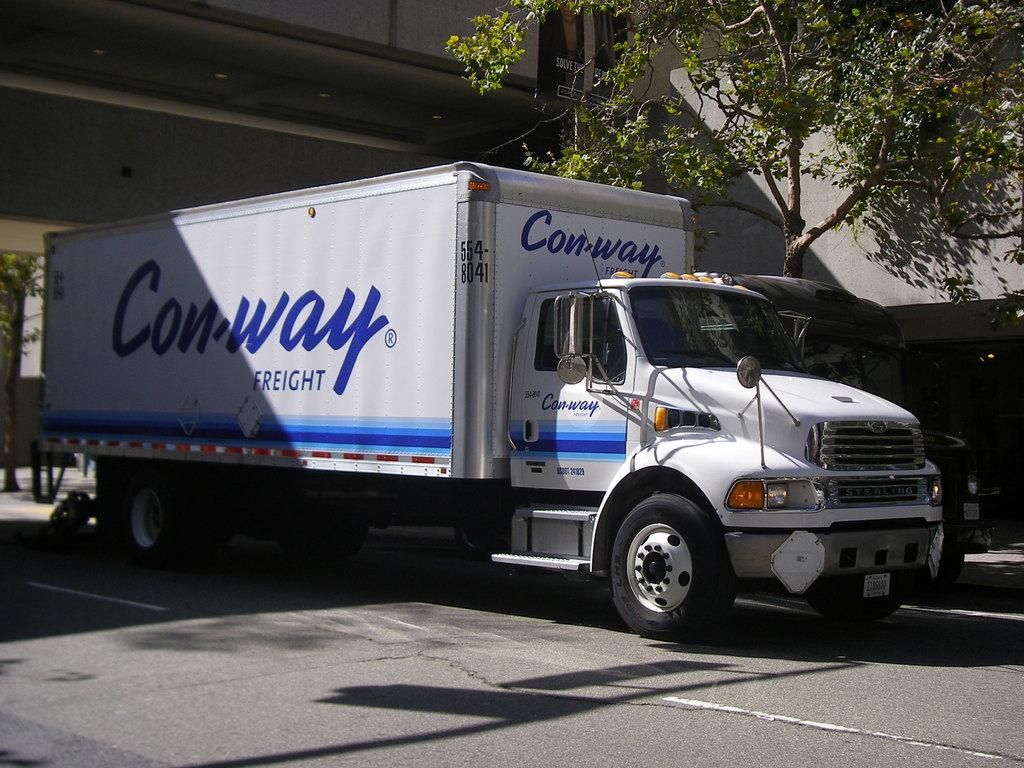What is the main subject of the image? The main subject of the image is a truck. Where is the truck located in the image? The truck is on the road in the image. What other object can be seen in the image? There is a tree in the image. What type of cork is being used to hold up the trousers in the image? There is no cork or trousers present in the image; it only features a truck on the road and a tree. 